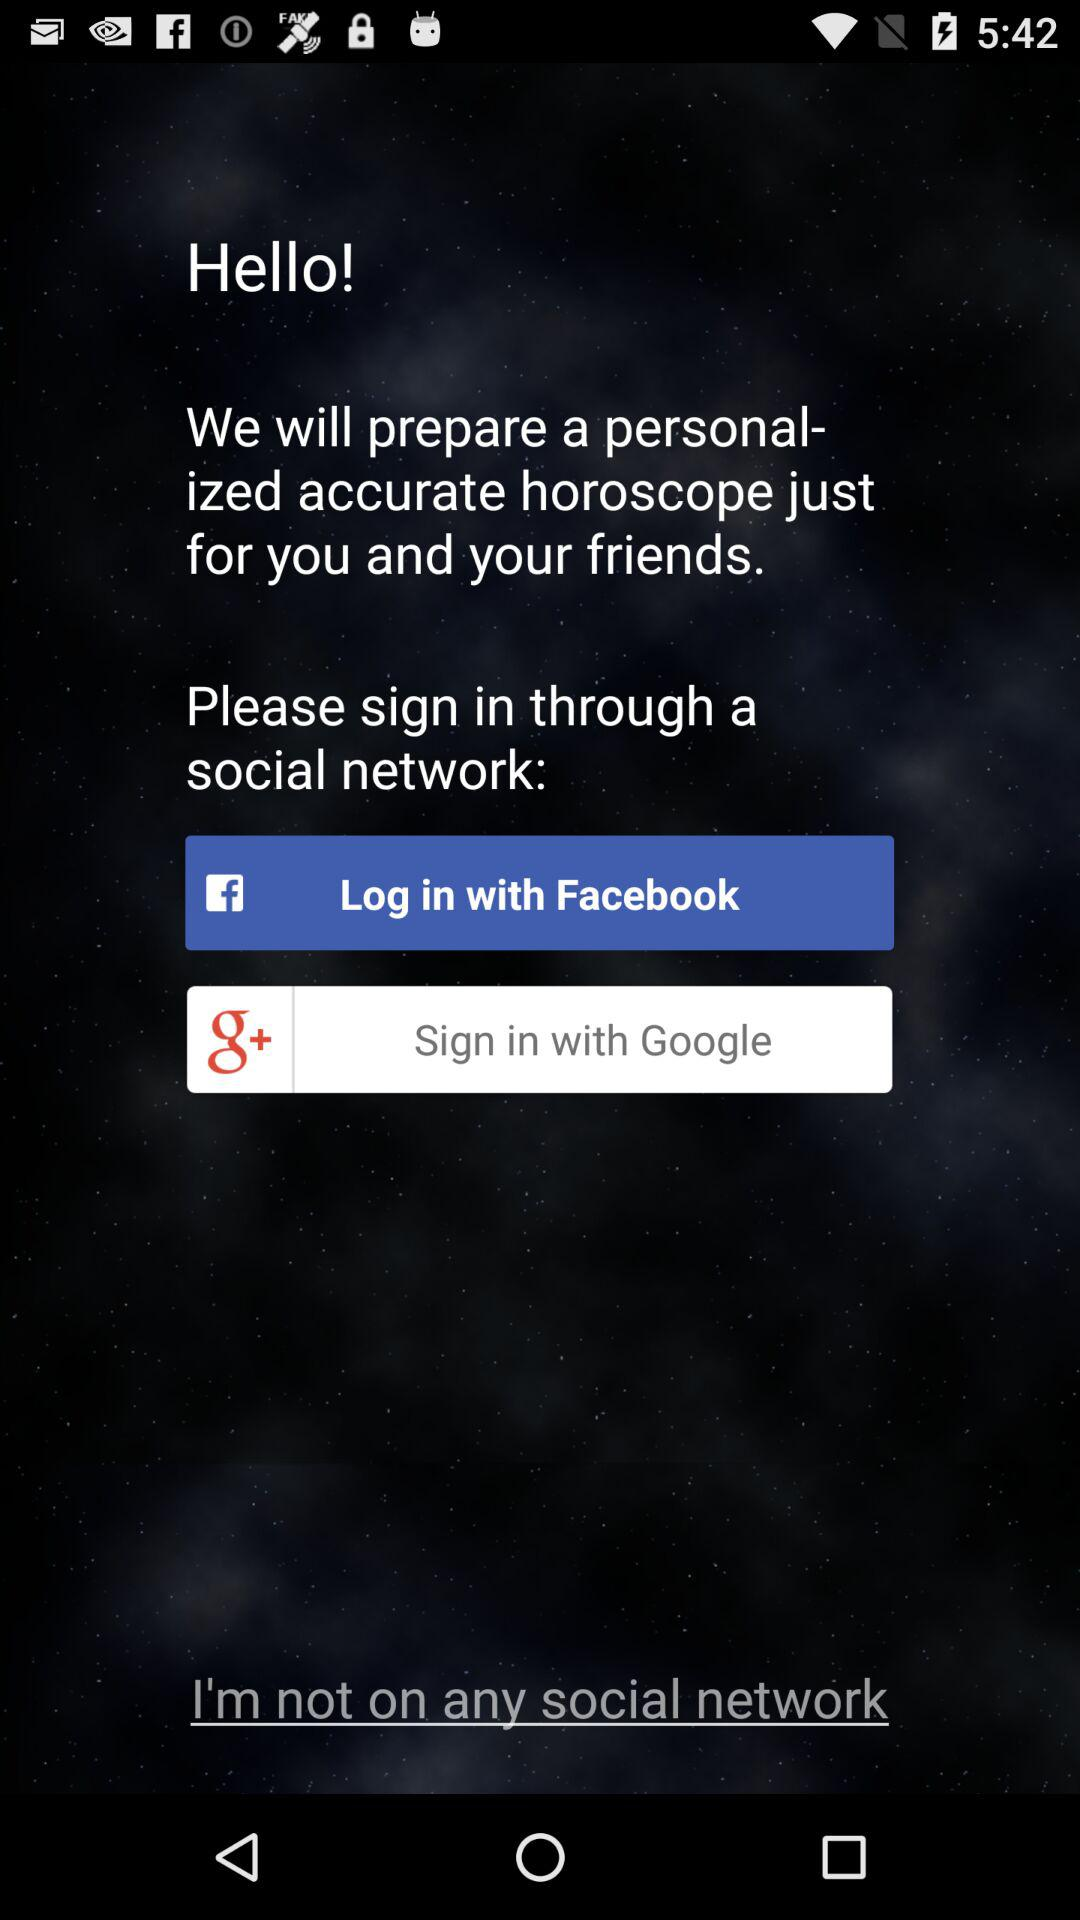Which sign-in option is selected?
When the provided information is insufficient, respond with <no answer>. <no answer> 